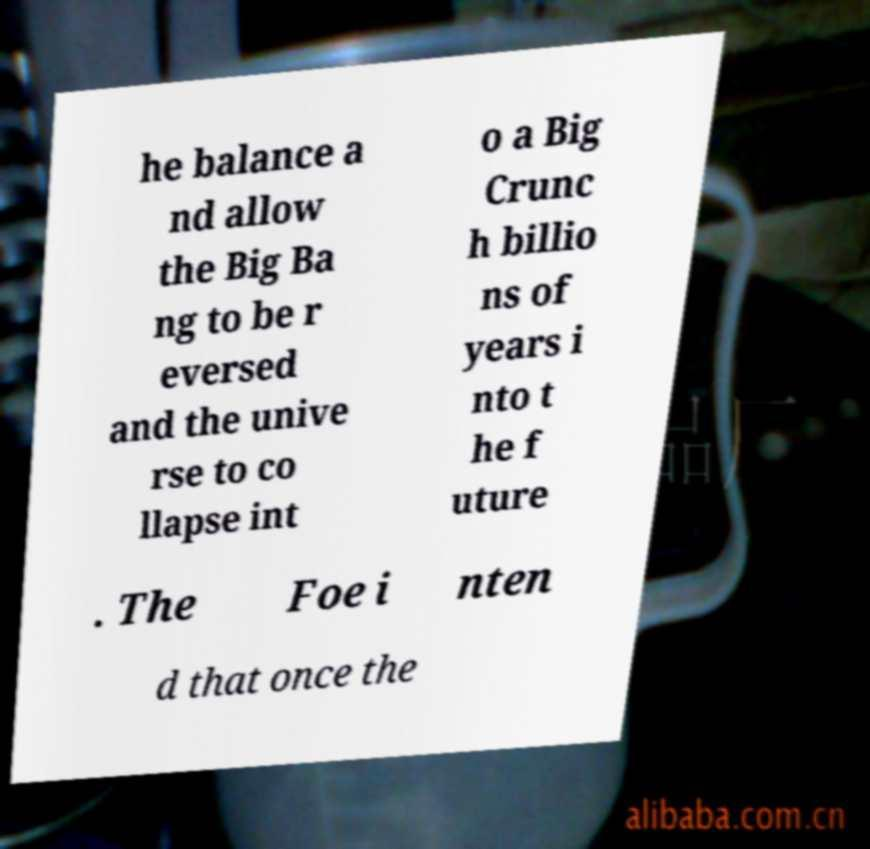Please identify and transcribe the text found in this image. he balance a nd allow the Big Ba ng to be r eversed and the unive rse to co llapse int o a Big Crunc h billio ns of years i nto t he f uture . The Foe i nten d that once the 